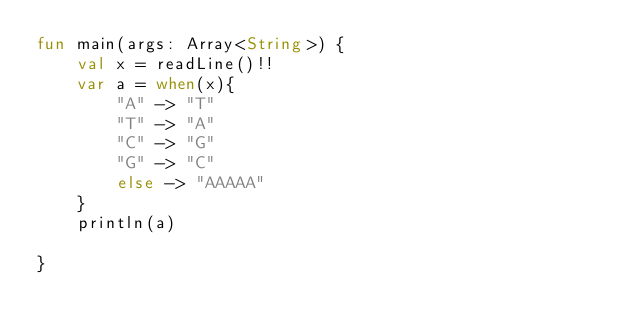Convert code to text. <code><loc_0><loc_0><loc_500><loc_500><_Kotlin_>fun main(args: Array<String>) {
    val x = readLine()!!
    var a = when(x){
        "A" -> "T"
        "T" -> "A"
        "C" -> "G"
        "G" -> "C"
        else -> "AAAAA"
    }
    println(a)

}</code> 